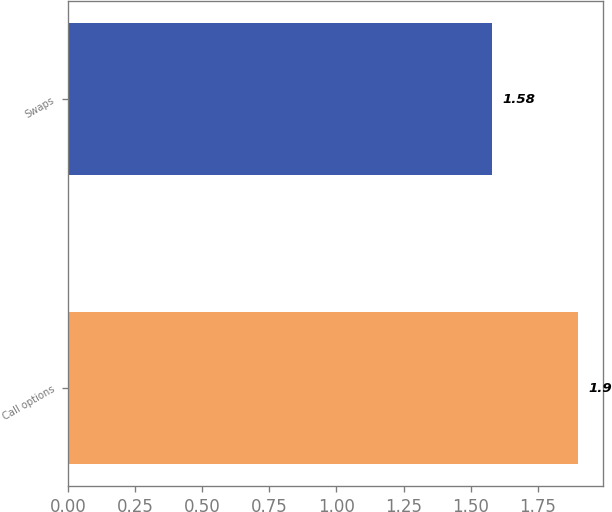Convert chart to OTSL. <chart><loc_0><loc_0><loc_500><loc_500><bar_chart><fcel>Call options<fcel>Swaps<nl><fcel>1.9<fcel>1.58<nl></chart> 